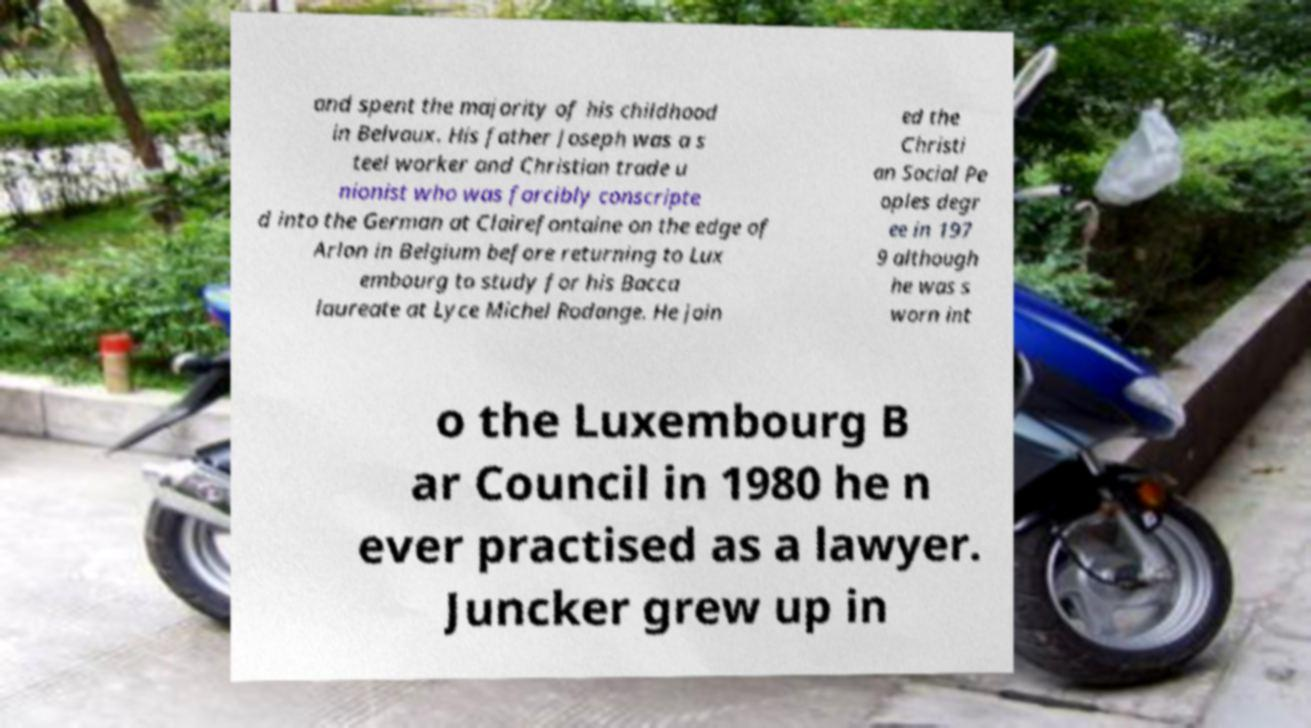For documentation purposes, I need the text within this image transcribed. Could you provide that? and spent the majority of his childhood in Belvaux. His father Joseph was a s teel worker and Christian trade u nionist who was forcibly conscripte d into the German at Clairefontaine on the edge of Arlon in Belgium before returning to Lux embourg to study for his Bacca laureate at Lyce Michel Rodange. He join ed the Christi an Social Pe oples degr ee in 197 9 although he was s worn int o the Luxembourg B ar Council in 1980 he n ever practised as a lawyer. Juncker grew up in 